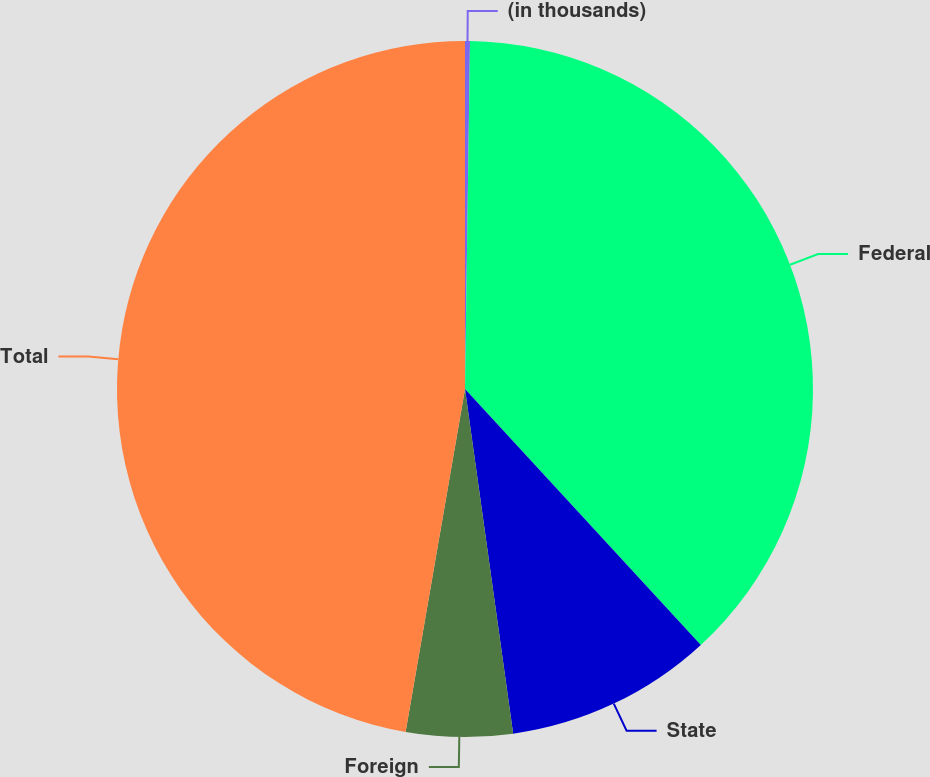Convert chart to OTSL. <chart><loc_0><loc_0><loc_500><loc_500><pie_chart><fcel>(in thousands)<fcel>Federal<fcel>State<fcel>Foreign<fcel>Total<nl><fcel>0.23%<fcel>37.92%<fcel>9.64%<fcel>4.94%<fcel>47.27%<nl></chart> 